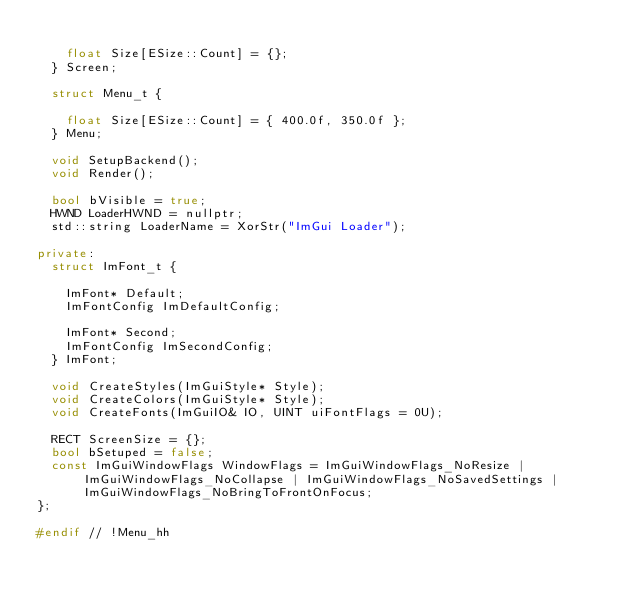Convert code to text. <code><loc_0><loc_0><loc_500><loc_500><_C++_>
		float Size[ESize::Count] = {};
	} Screen;

	struct Menu_t {

		float Size[ESize::Count] = { 400.0f, 350.0f };
	} Menu;

	void SetupBackend();
	void Render();

	bool bVisible = true;
	HWND LoaderHWND = nullptr;
	std::string LoaderName = XorStr("ImGui Loader");

private:
	struct ImFont_t {

		ImFont* Default;
		ImFontConfig ImDefaultConfig;

		ImFont* Second;
		ImFontConfig ImSecondConfig;
	} ImFont;

	void CreateStyles(ImGuiStyle* Style);
	void CreateColors(ImGuiStyle* Style);
	void CreateFonts(ImGuiIO& IO, UINT uiFontFlags = 0U);

	RECT ScreenSize = {};
	bool bSetuped = false;
	const ImGuiWindowFlags WindowFlags = ImGuiWindowFlags_NoResize | ImGuiWindowFlags_NoCollapse | ImGuiWindowFlags_NoSavedSettings | ImGuiWindowFlags_NoBringToFrontOnFocus;
};

#endif // !Menu_hh</code> 